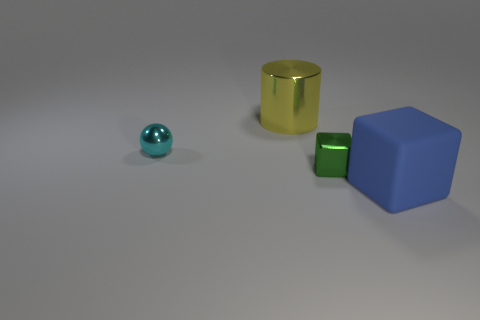How many large shiny cylinders have the same color as the tiny ball?
Your answer should be compact. 0. Is the size of the object that is behind the cyan shiny thing the same as the blue rubber block?
Ensure brevity in your answer.  Yes. There is a shiny object that is both to the right of the cyan shiny sphere and in front of the big cylinder; what is its color?
Provide a short and direct response. Green. How many things are cyan spheres or things on the left side of the big blue matte object?
Offer a very short reply. 3. There is a cube behind the large object that is right of the tiny shiny object that is in front of the tiny cyan object; what is it made of?
Offer a very short reply. Metal. Are there any other things that are made of the same material as the cyan ball?
Provide a short and direct response. Yes. How many red things are either large things or big cylinders?
Make the answer very short. 0. How many other objects are the same shape as the small cyan shiny object?
Make the answer very short. 0. Do the green cube and the blue object have the same material?
Keep it short and to the point. No. What material is the thing that is to the right of the yellow thing and on the left side of the rubber cube?
Provide a succinct answer. Metal. 